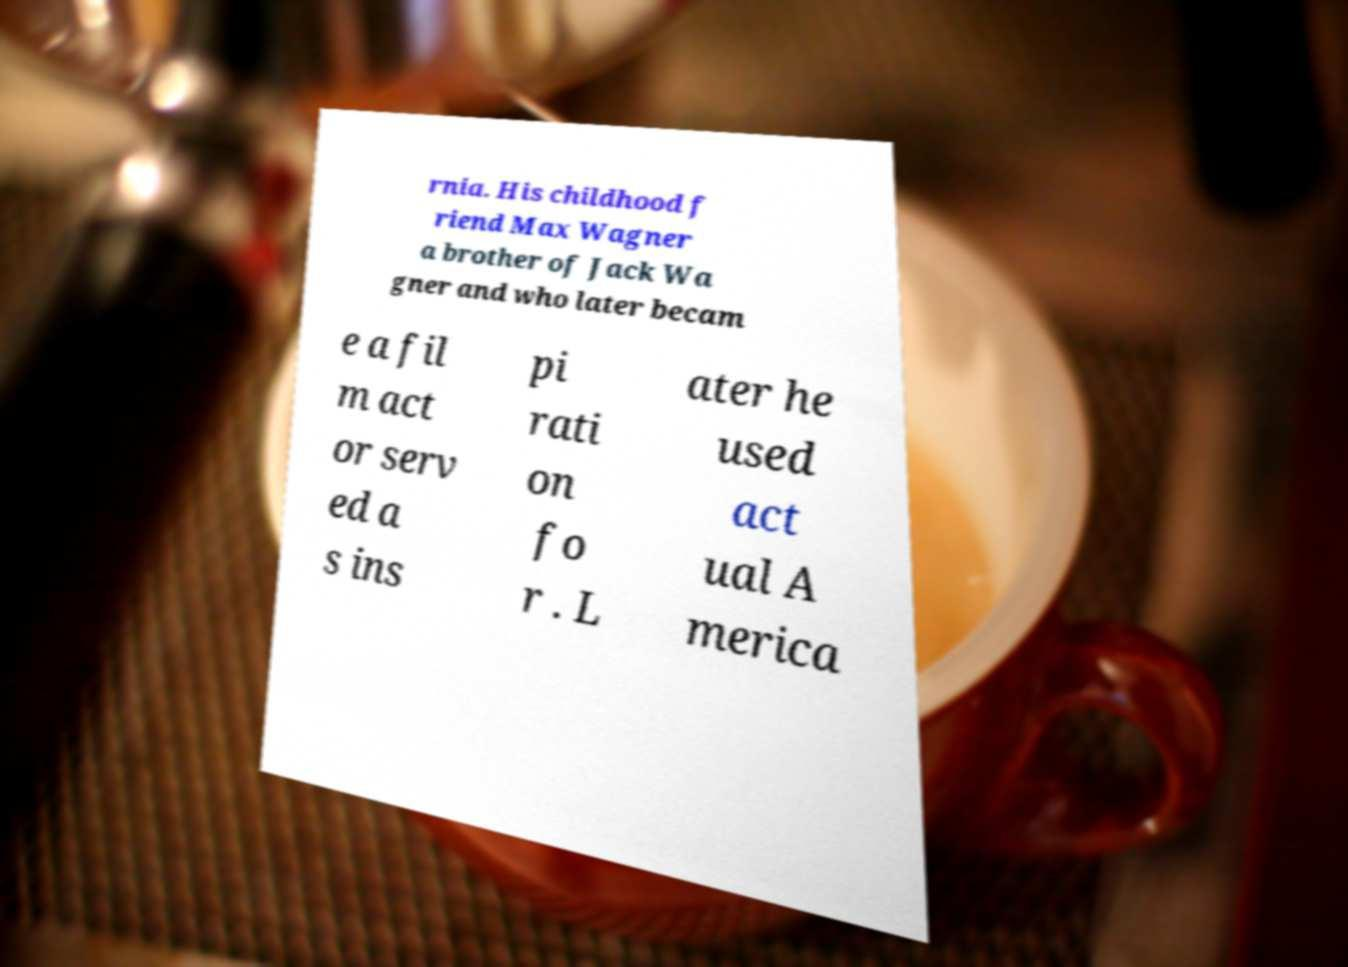What messages or text are displayed in this image? I need them in a readable, typed format. rnia. His childhood f riend Max Wagner a brother of Jack Wa gner and who later becam e a fil m act or serv ed a s ins pi rati on fo r . L ater he used act ual A merica 